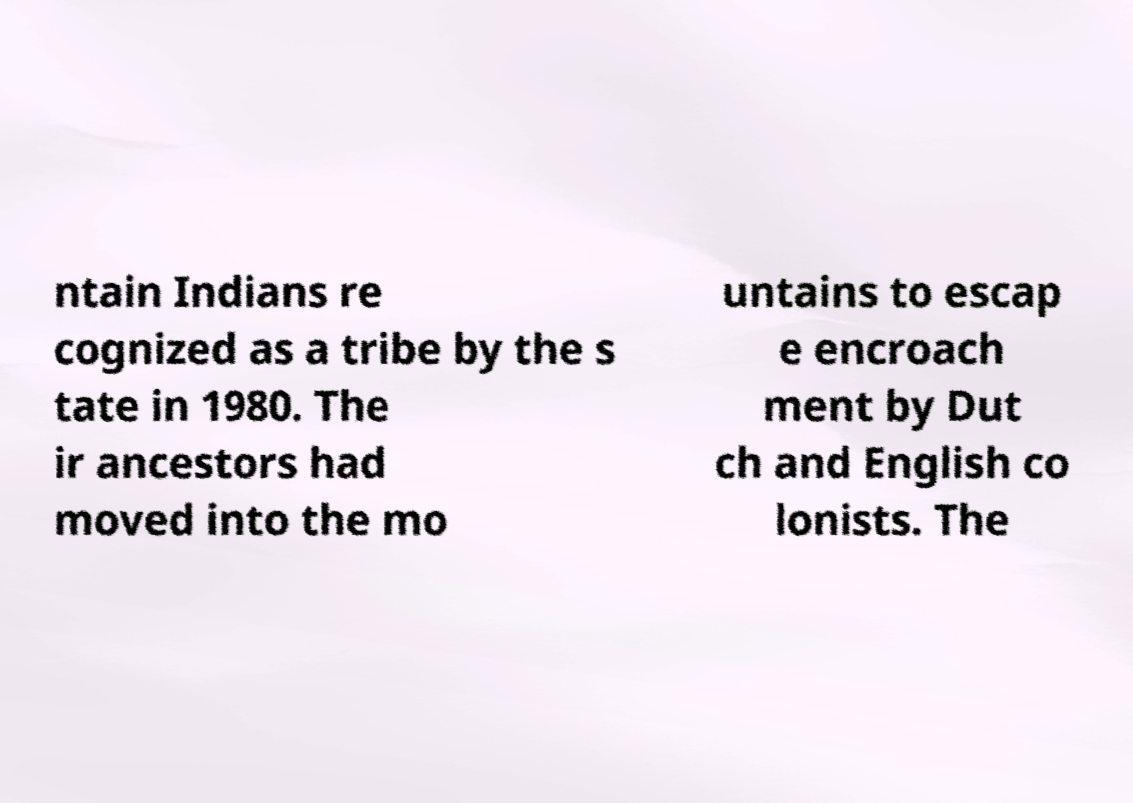Could you extract and type out the text from this image? ntain Indians re cognized as a tribe by the s tate in 1980. The ir ancestors had moved into the mo untains to escap e encroach ment by Dut ch and English co lonists. The 